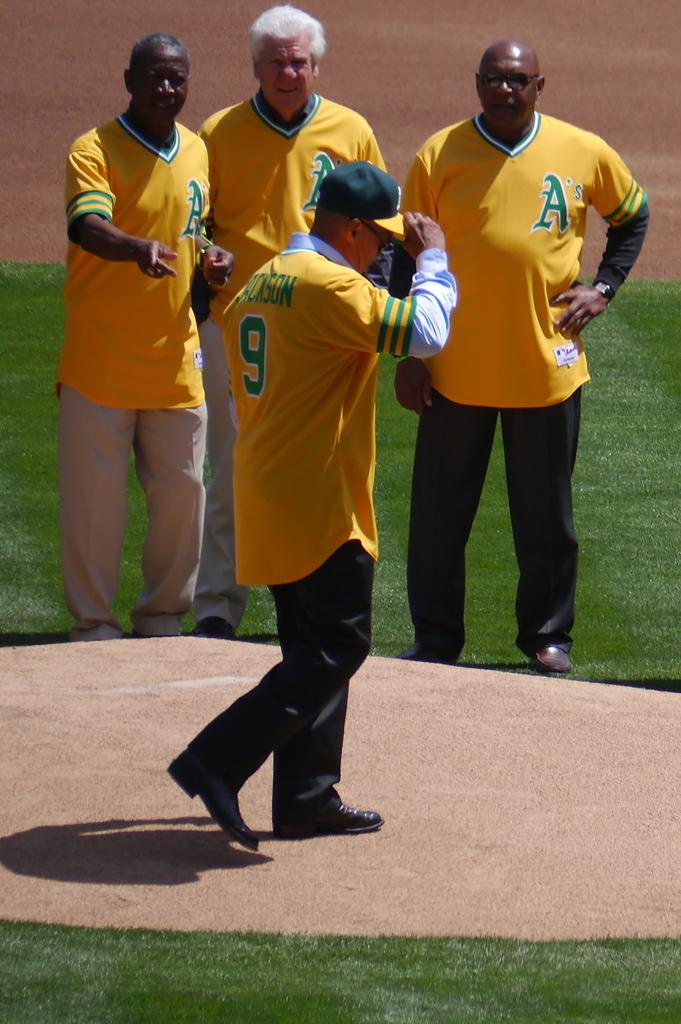<image>
Write a terse but informative summary of the picture. Reggie Jackson wears his old A's uniform while walking across the pitcher's mound. 